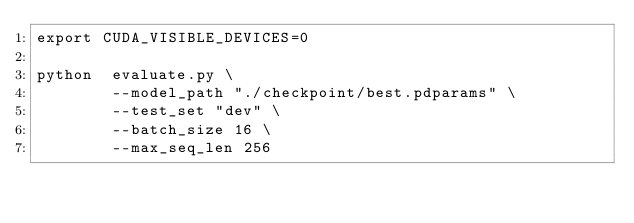Convert code to text. <code><loc_0><loc_0><loc_500><loc_500><_Bash_>export CUDA_VISIBLE_DEVICES=0

python  evaluate.py \
        --model_path "./checkpoint/best.pdparams" \
        --test_set "dev" \
        --batch_size 16 \
        --max_seq_len 256

</code> 